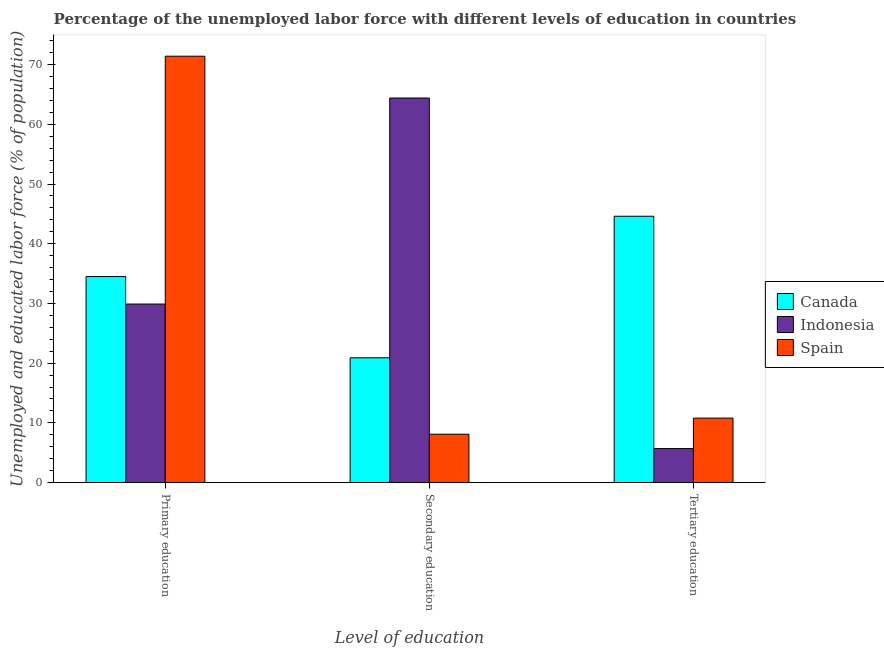How many different coloured bars are there?
Make the answer very short. 3. How many groups of bars are there?
Keep it short and to the point. 3. Are the number of bars on each tick of the X-axis equal?
Give a very brief answer. Yes. How many bars are there on the 2nd tick from the left?
Offer a very short reply. 3. What is the label of the 2nd group of bars from the left?
Provide a succinct answer. Secondary education. What is the percentage of labor force who received primary education in Spain?
Offer a very short reply. 71.4. Across all countries, what is the maximum percentage of labor force who received secondary education?
Make the answer very short. 64.4. Across all countries, what is the minimum percentage of labor force who received primary education?
Provide a succinct answer. 29.9. In which country was the percentage of labor force who received secondary education maximum?
Your response must be concise. Indonesia. In which country was the percentage of labor force who received primary education minimum?
Provide a short and direct response. Indonesia. What is the total percentage of labor force who received secondary education in the graph?
Ensure brevity in your answer.  93.4. What is the difference between the percentage of labor force who received secondary education in Indonesia and that in Spain?
Ensure brevity in your answer.  56.3. What is the difference between the percentage of labor force who received secondary education in Indonesia and the percentage of labor force who received tertiary education in Spain?
Your response must be concise. 53.6. What is the average percentage of labor force who received tertiary education per country?
Your answer should be very brief. 20.37. What is the difference between the percentage of labor force who received tertiary education and percentage of labor force who received secondary education in Spain?
Keep it short and to the point. 2.7. In how many countries, is the percentage of labor force who received primary education greater than 70 %?
Offer a very short reply. 1. What is the ratio of the percentage of labor force who received primary education in Indonesia to that in Spain?
Your answer should be very brief. 0.42. Is the difference between the percentage of labor force who received primary education in Canada and Indonesia greater than the difference between the percentage of labor force who received secondary education in Canada and Indonesia?
Your answer should be compact. Yes. What is the difference between the highest and the second highest percentage of labor force who received tertiary education?
Your response must be concise. 33.8. What is the difference between the highest and the lowest percentage of labor force who received primary education?
Provide a succinct answer. 41.5. In how many countries, is the percentage of labor force who received secondary education greater than the average percentage of labor force who received secondary education taken over all countries?
Provide a short and direct response. 1. Is the sum of the percentage of labor force who received secondary education in Indonesia and Spain greater than the maximum percentage of labor force who received tertiary education across all countries?
Offer a very short reply. Yes. Is it the case that in every country, the sum of the percentage of labor force who received primary education and percentage of labor force who received secondary education is greater than the percentage of labor force who received tertiary education?
Your answer should be very brief. Yes. How many countries are there in the graph?
Your answer should be compact. 3. What is the difference between two consecutive major ticks on the Y-axis?
Provide a short and direct response. 10. Are the values on the major ticks of Y-axis written in scientific E-notation?
Your answer should be compact. No. Does the graph contain any zero values?
Give a very brief answer. No. How many legend labels are there?
Offer a terse response. 3. What is the title of the graph?
Ensure brevity in your answer.  Percentage of the unemployed labor force with different levels of education in countries. Does "St. Vincent and the Grenadines" appear as one of the legend labels in the graph?
Offer a very short reply. No. What is the label or title of the X-axis?
Your response must be concise. Level of education. What is the label or title of the Y-axis?
Give a very brief answer. Unemployed and educated labor force (% of population). What is the Unemployed and educated labor force (% of population) in Canada in Primary education?
Provide a succinct answer. 34.5. What is the Unemployed and educated labor force (% of population) of Indonesia in Primary education?
Make the answer very short. 29.9. What is the Unemployed and educated labor force (% of population) in Spain in Primary education?
Give a very brief answer. 71.4. What is the Unemployed and educated labor force (% of population) of Canada in Secondary education?
Ensure brevity in your answer.  20.9. What is the Unemployed and educated labor force (% of population) in Indonesia in Secondary education?
Keep it short and to the point. 64.4. What is the Unemployed and educated labor force (% of population) of Spain in Secondary education?
Give a very brief answer. 8.1. What is the Unemployed and educated labor force (% of population) in Canada in Tertiary education?
Keep it short and to the point. 44.6. What is the Unemployed and educated labor force (% of population) in Indonesia in Tertiary education?
Make the answer very short. 5.7. What is the Unemployed and educated labor force (% of population) of Spain in Tertiary education?
Provide a succinct answer. 10.8. Across all Level of education, what is the maximum Unemployed and educated labor force (% of population) of Canada?
Keep it short and to the point. 44.6. Across all Level of education, what is the maximum Unemployed and educated labor force (% of population) in Indonesia?
Ensure brevity in your answer.  64.4. Across all Level of education, what is the maximum Unemployed and educated labor force (% of population) of Spain?
Provide a succinct answer. 71.4. Across all Level of education, what is the minimum Unemployed and educated labor force (% of population) of Canada?
Your answer should be very brief. 20.9. Across all Level of education, what is the minimum Unemployed and educated labor force (% of population) in Indonesia?
Make the answer very short. 5.7. Across all Level of education, what is the minimum Unemployed and educated labor force (% of population) of Spain?
Make the answer very short. 8.1. What is the total Unemployed and educated labor force (% of population) of Canada in the graph?
Make the answer very short. 100. What is the total Unemployed and educated labor force (% of population) of Spain in the graph?
Ensure brevity in your answer.  90.3. What is the difference between the Unemployed and educated labor force (% of population) of Canada in Primary education and that in Secondary education?
Keep it short and to the point. 13.6. What is the difference between the Unemployed and educated labor force (% of population) of Indonesia in Primary education and that in Secondary education?
Make the answer very short. -34.5. What is the difference between the Unemployed and educated labor force (% of population) in Spain in Primary education and that in Secondary education?
Ensure brevity in your answer.  63.3. What is the difference between the Unemployed and educated labor force (% of population) of Canada in Primary education and that in Tertiary education?
Provide a short and direct response. -10.1. What is the difference between the Unemployed and educated labor force (% of population) of Indonesia in Primary education and that in Tertiary education?
Keep it short and to the point. 24.2. What is the difference between the Unemployed and educated labor force (% of population) in Spain in Primary education and that in Tertiary education?
Offer a very short reply. 60.6. What is the difference between the Unemployed and educated labor force (% of population) in Canada in Secondary education and that in Tertiary education?
Provide a succinct answer. -23.7. What is the difference between the Unemployed and educated labor force (% of population) of Indonesia in Secondary education and that in Tertiary education?
Offer a terse response. 58.7. What is the difference between the Unemployed and educated labor force (% of population) of Canada in Primary education and the Unemployed and educated labor force (% of population) of Indonesia in Secondary education?
Provide a succinct answer. -29.9. What is the difference between the Unemployed and educated labor force (% of population) in Canada in Primary education and the Unemployed and educated labor force (% of population) in Spain in Secondary education?
Offer a terse response. 26.4. What is the difference between the Unemployed and educated labor force (% of population) of Indonesia in Primary education and the Unemployed and educated labor force (% of population) of Spain in Secondary education?
Give a very brief answer. 21.8. What is the difference between the Unemployed and educated labor force (% of population) of Canada in Primary education and the Unemployed and educated labor force (% of population) of Indonesia in Tertiary education?
Keep it short and to the point. 28.8. What is the difference between the Unemployed and educated labor force (% of population) of Canada in Primary education and the Unemployed and educated labor force (% of population) of Spain in Tertiary education?
Keep it short and to the point. 23.7. What is the difference between the Unemployed and educated labor force (% of population) of Indonesia in Secondary education and the Unemployed and educated labor force (% of population) of Spain in Tertiary education?
Provide a short and direct response. 53.6. What is the average Unemployed and educated labor force (% of population) of Canada per Level of education?
Your response must be concise. 33.33. What is the average Unemployed and educated labor force (% of population) of Indonesia per Level of education?
Keep it short and to the point. 33.33. What is the average Unemployed and educated labor force (% of population) of Spain per Level of education?
Offer a terse response. 30.1. What is the difference between the Unemployed and educated labor force (% of population) in Canada and Unemployed and educated labor force (% of population) in Spain in Primary education?
Make the answer very short. -36.9. What is the difference between the Unemployed and educated labor force (% of population) of Indonesia and Unemployed and educated labor force (% of population) of Spain in Primary education?
Provide a short and direct response. -41.5. What is the difference between the Unemployed and educated labor force (% of population) of Canada and Unemployed and educated labor force (% of population) of Indonesia in Secondary education?
Make the answer very short. -43.5. What is the difference between the Unemployed and educated labor force (% of population) of Canada and Unemployed and educated labor force (% of population) of Spain in Secondary education?
Give a very brief answer. 12.8. What is the difference between the Unemployed and educated labor force (% of population) in Indonesia and Unemployed and educated labor force (% of population) in Spain in Secondary education?
Ensure brevity in your answer.  56.3. What is the difference between the Unemployed and educated labor force (% of population) of Canada and Unemployed and educated labor force (% of population) of Indonesia in Tertiary education?
Your answer should be compact. 38.9. What is the difference between the Unemployed and educated labor force (% of population) of Canada and Unemployed and educated labor force (% of population) of Spain in Tertiary education?
Provide a succinct answer. 33.8. What is the difference between the Unemployed and educated labor force (% of population) in Indonesia and Unemployed and educated labor force (% of population) in Spain in Tertiary education?
Your answer should be very brief. -5.1. What is the ratio of the Unemployed and educated labor force (% of population) of Canada in Primary education to that in Secondary education?
Give a very brief answer. 1.65. What is the ratio of the Unemployed and educated labor force (% of population) of Indonesia in Primary education to that in Secondary education?
Ensure brevity in your answer.  0.46. What is the ratio of the Unemployed and educated labor force (% of population) of Spain in Primary education to that in Secondary education?
Make the answer very short. 8.81. What is the ratio of the Unemployed and educated labor force (% of population) in Canada in Primary education to that in Tertiary education?
Your response must be concise. 0.77. What is the ratio of the Unemployed and educated labor force (% of population) in Indonesia in Primary education to that in Tertiary education?
Provide a short and direct response. 5.25. What is the ratio of the Unemployed and educated labor force (% of population) in Spain in Primary education to that in Tertiary education?
Your answer should be compact. 6.61. What is the ratio of the Unemployed and educated labor force (% of population) of Canada in Secondary education to that in Tertiary education?
Provide a succinct answer. 0.47. What is the ratio of the Unemployed and educated labor force (% of population) of Indonesia in Secondary education to that in Tertiary education?
Offer a very short reply. 11.3. What is the ratio of the Unemployed and educated labor force (% of population) in Spain in Secondary education to that in Tertiary education?
Ensure brevity in your answer.  0.75. What is the difference between the highest and the second highest Unemployed and educated labor force (% of population) of Indonesia?
Your answer should be compact. 34.5. What is the difference between the highest and the second highest Unemployed and educated labor force (% of population) in Spain?
Provide a short and direct response. 60.6. What is the difference between the highest and the lowest Unemployed and educated labor force (% of population) of Canada?
Offer a terse response. 23.7. What is the difference between the highest and the lowest Unemployed and educated labor force (% of population) of Indonesia?
Your answer should be compact. 58.7. What is the difference between the highest and the lowest Unemployed and educated labor force (% of population) of Spain?
Offer a very short reply. 63.3. 